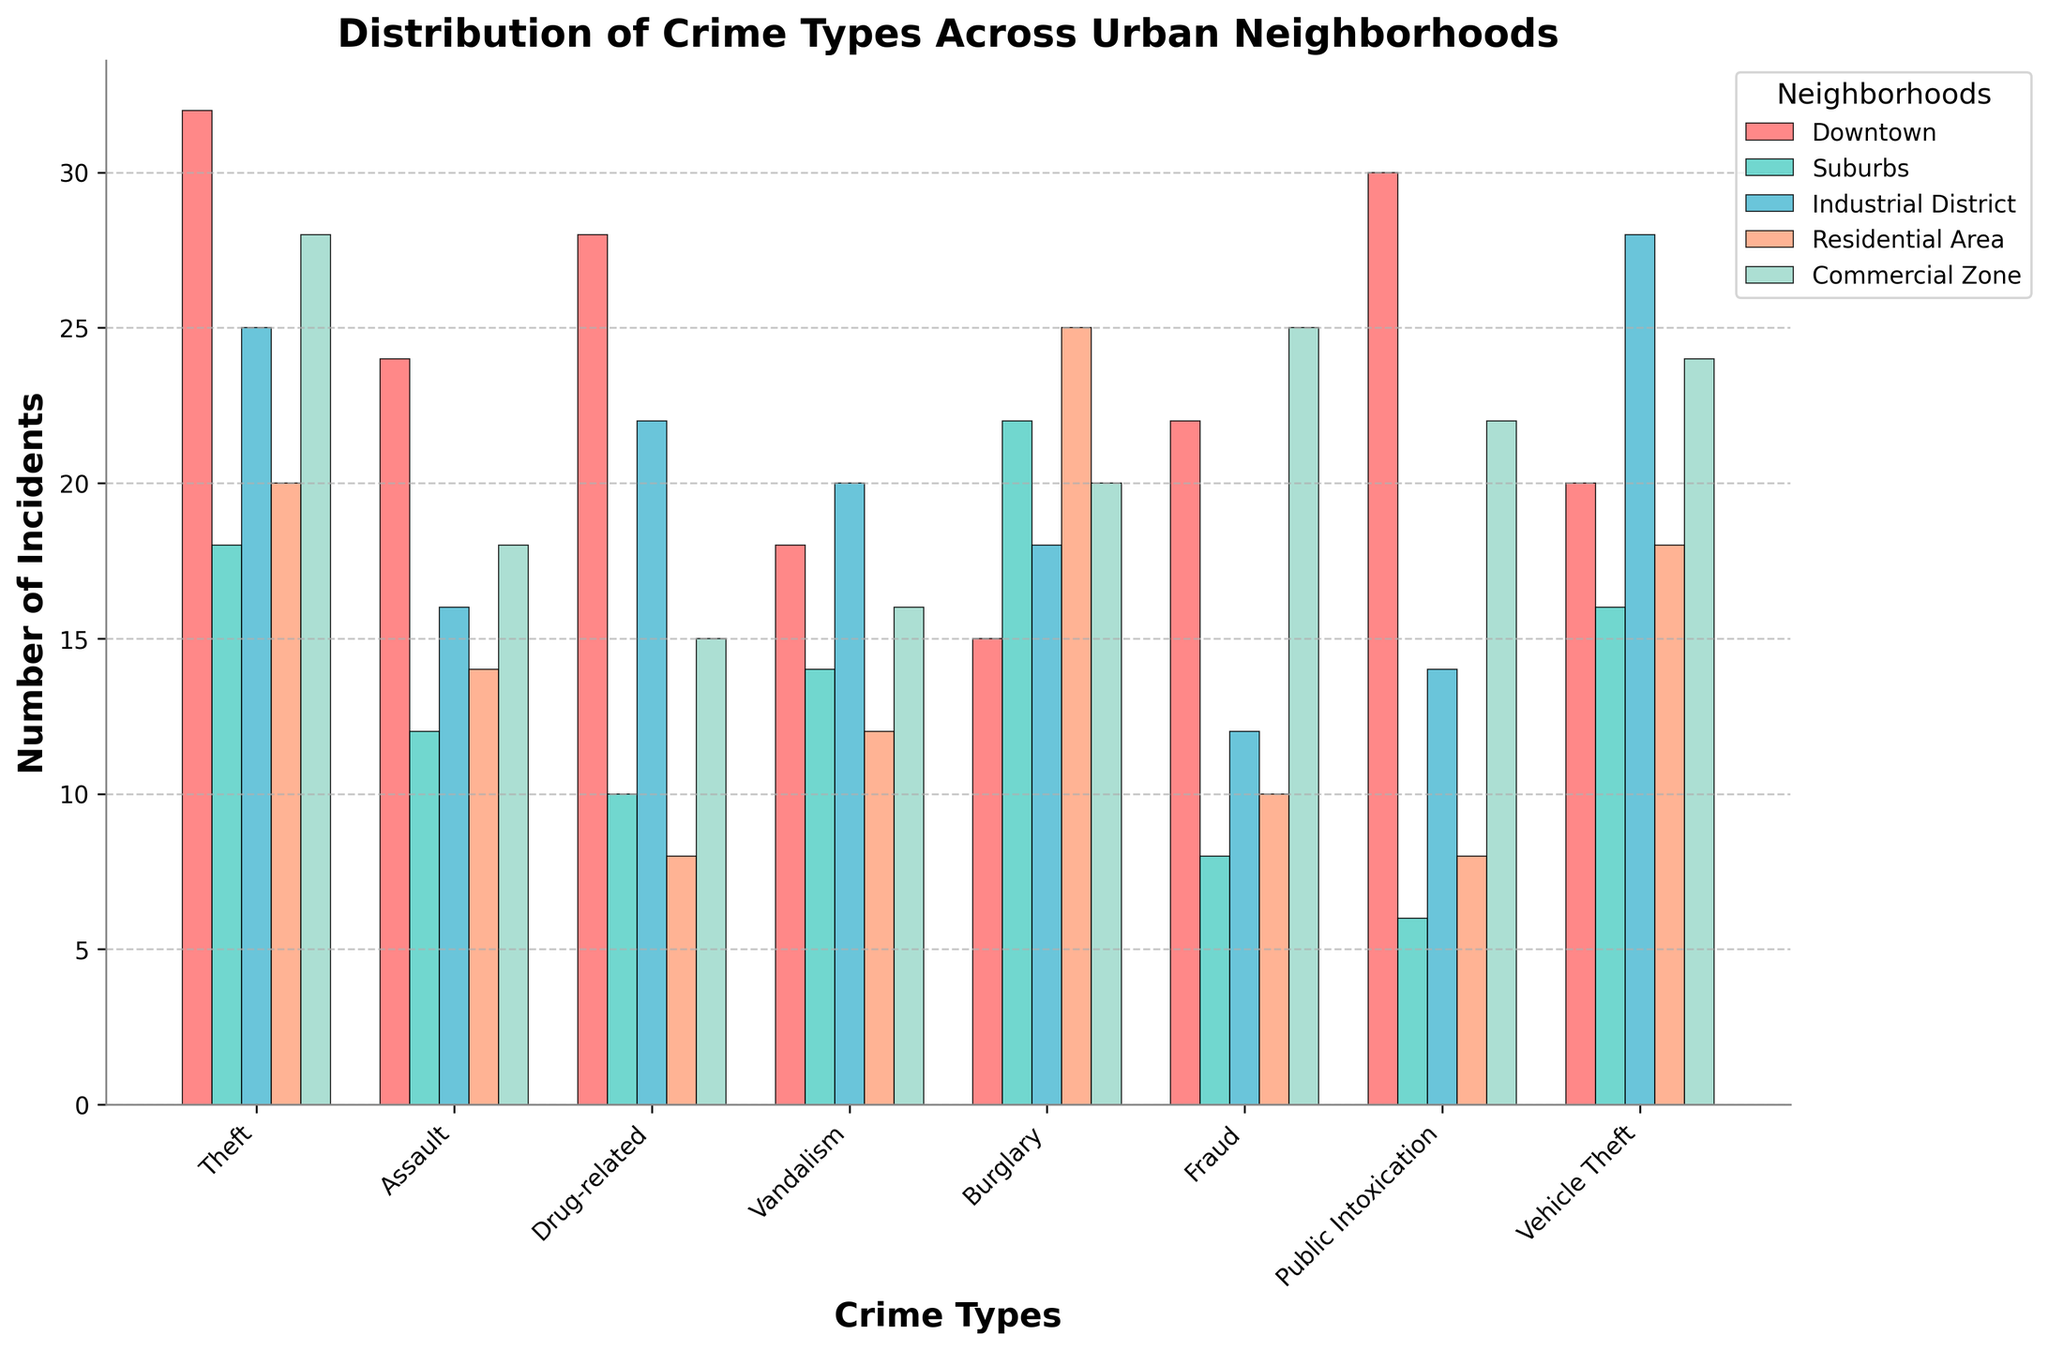What's the title of the figure? The title of the figure is usually located at the top of the plot. In this case, it is a textual element stating what the plot is about.
Answer: Distribution of Crime Types Across Urban Neighborhoods Which neighborhood has the highest number of Theft incidents? To determine this, locate the bars representing "Theft" incidents. Compare the height of the bars for each neighborhood. The highest bar indicates the neighborhood with the most incidents.
Answer: Downtown How many Assault incidents occurred in the Residential Area? Find the bar for "Assault" under the "Residential Area" section. The height of that bar, or the label above it, shows the number of incidents.
Answer: 14 What's the difference in the number of Public Intoxication incidents between Downtown and the Suburbs? Identify and compare the heights of the Public Intoxication bars for Downtown and the Suburbs. Subtract the smaller value from the larger one. Downtown has 30 incidents, and the Suburbs have 6.
Answer: 24 Which crime type has the least number of incidents in the Industrial District? Look at the bars in the Industrial District group and find the shortest one. The label on this bar indicates the crime type with the least incidents.
Answer: Fraud Which neighborhood has the most varied distribution of crime types? Observe the spread of the bars for each neighborhood. The neighborhood with the most significant difference between its highest and lowest crime incidents shows the most varied distribution.
Answer: Downtown Among all neighborhoods, which crime type has the highest total number of incidents? Sum the bars for each crime type across all neighborhoods. The crime type with the highest sum is the one with the most incidents. Theft: 123, Assault: 84, Drug-related: 83, Vandalism: 80, Burglary: 100, Fraud: 77, Public Intoxication: 80, Vehicle Theft: 106
Answer: Theft Which two neighborhoods have equal numbers of incidents for Vandalism? Find the bars for Vandalism in each neighborhood. Compare their heights and find the two neighborhoods with bars of equal height. Both Downtown and Industrial District have 20 incidents.
Answer: Downtown, Industrial District 